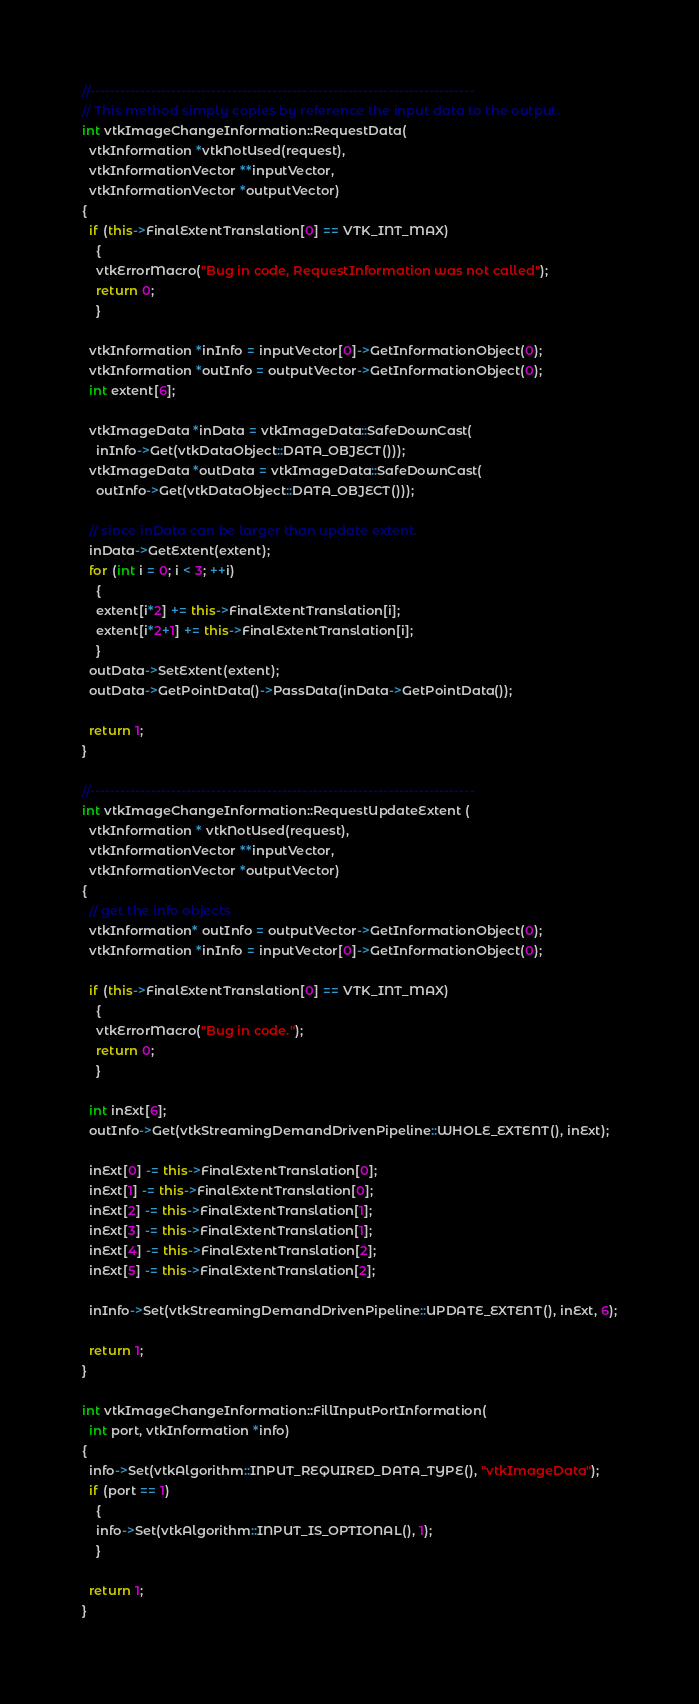<code> <loc_0><loc_0><loc_500><loc_500><_C++_>//----------------------------------------------------------------------------
// This method simply copies by reference the input data to the output.
int vtkImageChangeInformation::RequestData(
  vtkInformation *vtkNotUsed(request),
  vtkInformationVector **inputVector,
  vtkInformationVector *outputVector)
{
  if (this->FinalExtentTranslation[0] == VTK_INT_MAX)
    {
    vtkErrorMacro("Bug in code, RequestInformation was not called");
    return 0;
    }

  vtkInformation *inInfo = inputVector[0]->GetInformationObject(0);
  vtkInformation *outInfo = outputVector->GetInformationObject(0);
  int extent[6];
  
  vtkImageData *inData = vtkImageData::SafeDownCast(
    inInfo->Get(vtkDataObject::DATA_OBJECT()));
  vtkImageData *outData = vtkImageData::SafeDownCast(
    outInfo->Get(vtkDataObject::DATA_OBJECT()));

  // since inData can be larger than update extent.
  inData->GetExtent(extent);
  for (int i = 0; i < 3; ++i)
    {
    extent[i*2] += this->FinalExtentTranslation[i];
    extent[i*2+1] += this->FinalExtentTranslation[i];
    }
  outData->SetExtent(extent);
  outData->GetPointData()->PassData(inData->GetPointData());

  return 1;
}

//----------------------------------------------------------------------------
int vtkImageChangeInformation::RequestUpdateExtent (
  vtkInformation * vtkNotUsed(request),
  vtkInformationVector **inputVector,
  vtkInformationVector *outputVector)
{
  // get the info objects
  vtkInformation* outInfo = outputVector->GetInformationObject(0);
  vtkInformation *inInfo = inputVector[0]->GetInformationObject(0);

  if (this->FinalExtentTranslation[0] == VTK_INT_MAX)
    {
    vtkErrorMacro("Bug in code.");
    return 0;
    }

  int inExt[6];
  outInfo->Get(vtkStreamingDemandDrivenPipeline::WHOLE_EXTENT(), inExt);
  
  inExt[0] -= this->FinalExtentTranslation[0];
  inExt[1] -= this->FinalExtentTranslation[0];
  inExt[2] -= this->FinalExtentTranslation[1];
  inExt[3] -= this->FinalExtentTranslation[1];
  inExt[4] -= this->FinalExtentTranslation[2];
  inExt[5] -= this->FinalExtentTranslation[2];

  inInfo->Set(vtkStreamingDemandDrivenPipeline::UPDATE_EXTENT(), inExt, 6);

  return 1;
}

int vtkImageChangeInformation::FillInputPortInformation(
  int port, vtkInformation *info)
{
  info->Set(vtkAlgorithm::INPUT_REQUIRED_DATA_TYPE(), "vtkImageData");
  if (port == 1)
    {
    info->Set(vtkAlgorithm::INPUT_IS_OPTIONAL(), 1);
    }

  return 1;
}
</code> 